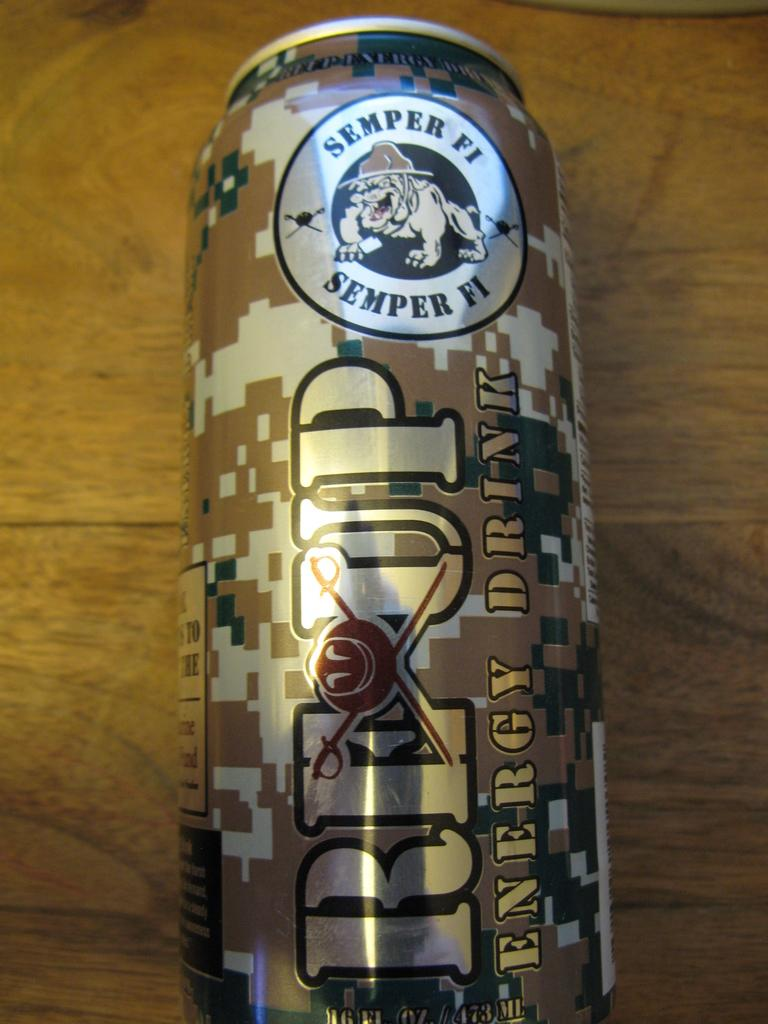Provide a one-sentence caption for the provided image. a semper fi can that is on a brown surface. 